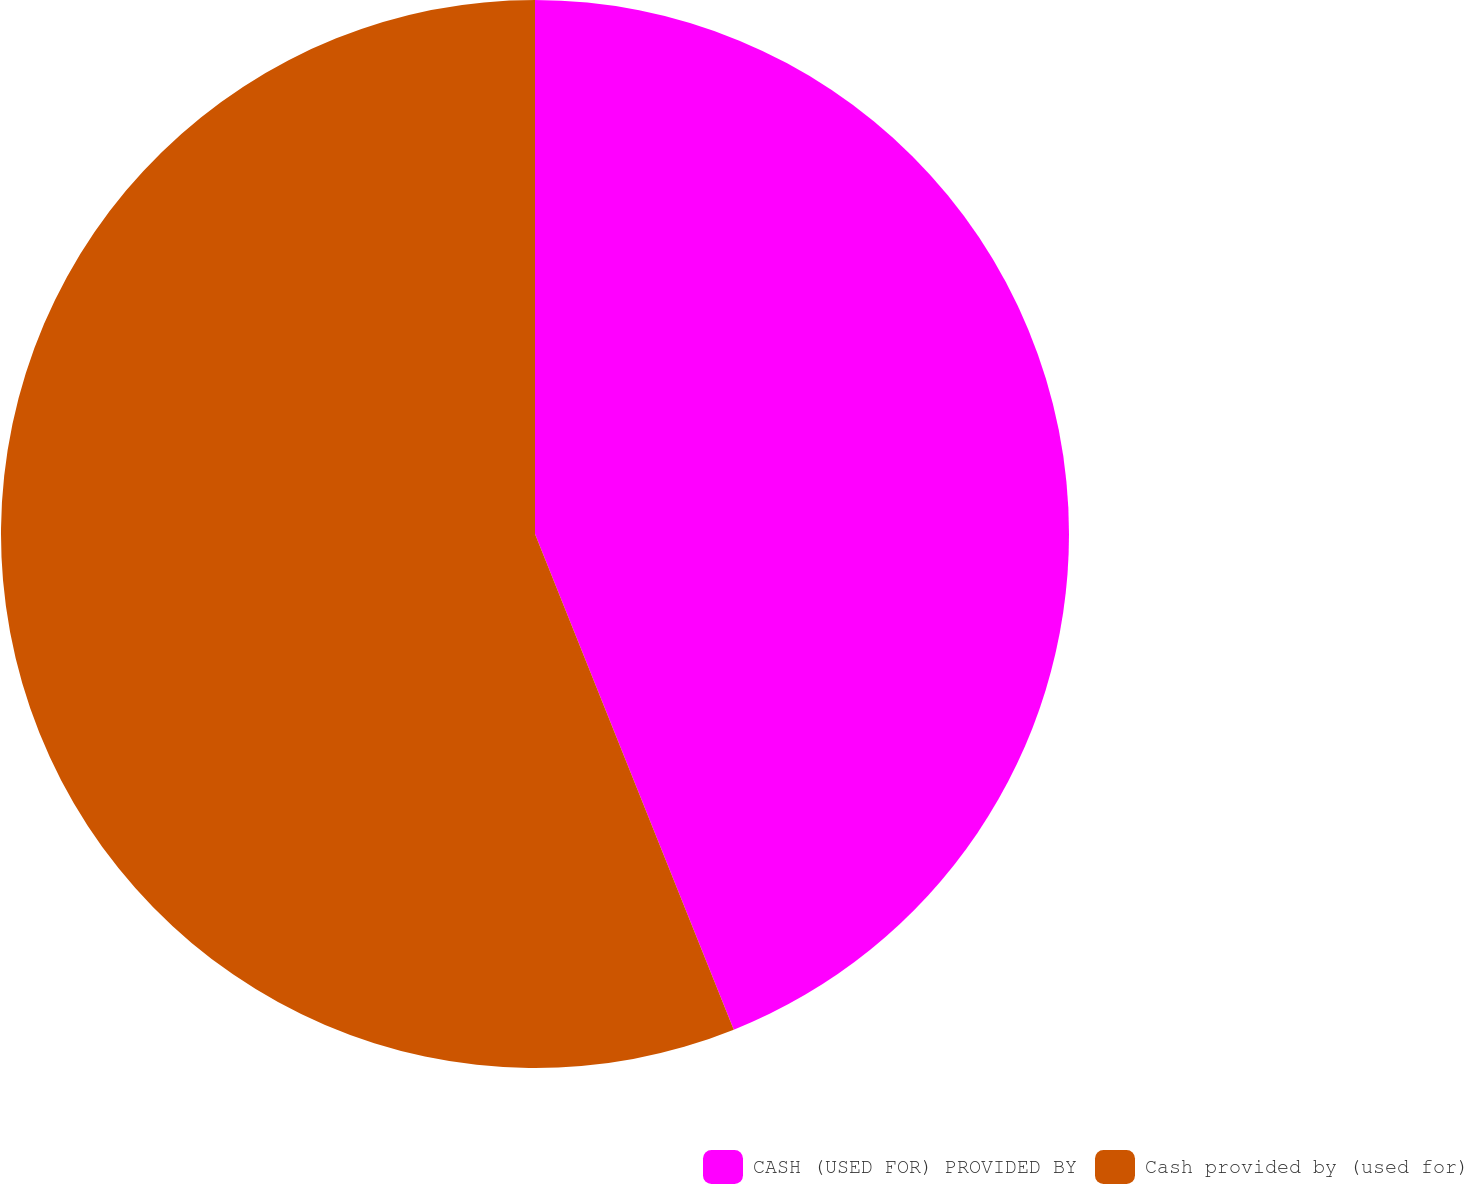Convert chart to OTSL. <chart><loc_0><loc_0><loc_500><loc_500><pie_chart><fcel>CASH (USED FOR) PROVIDED BY<fcel>Cash provided by (used for)<nl><fcel>43.93%<fcel>56.07%<nl></chart> 